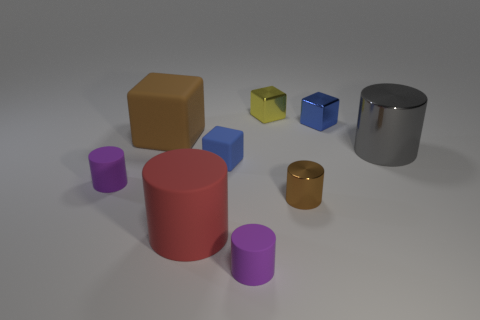Subtract all gray cylinders. How many cylinders are left? 4 Subtract all brown cylinders. How many cylinders are left? 4 Subtract all cyan cylinders. Subtract all cyan balls. How many cylinders are left? 5 Add 1 big cylinders. How many objects exist? 10 Subtract all cubes. How many objects are left? 5 Add 5 small matte blocks. How many small matte blocks exist? 6 Subtract 0 purple spheres. How many objects are left? 9 Subtract all matte objects. Subtract all tiny rubber blocks. How many objects are left? 3 Add 2 yellow shiny blocks. How many yellow shiny blocks are left? 3 